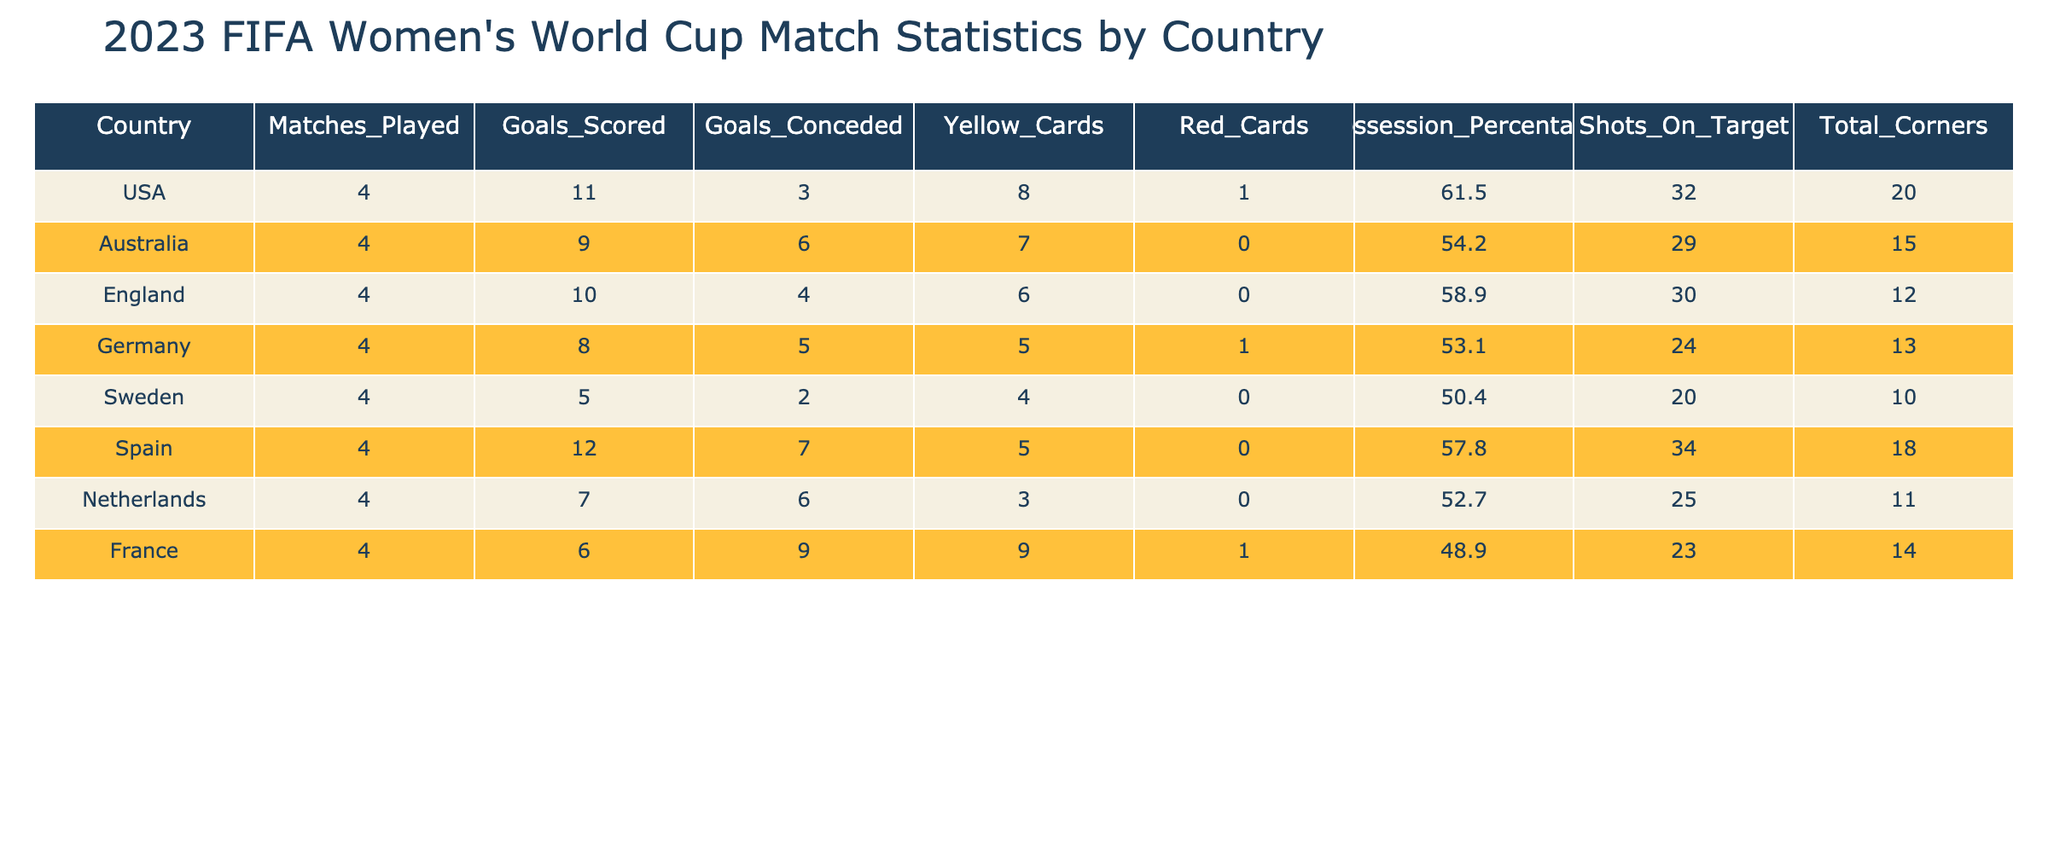What country scored the most goals? The table shows the "Goals_Scored" column for each country. By looking at the figures, Spain scored the most goals with a total of 12.
Answer: Spain Which country had the highest possession percentage? The "Possession_Percentage" column indicates how much time each country possessed the ball. The USA had the highest possession percentage at 61.5.
Answer: USA Did any country receive more than 9 yellow cards? By examining the "Yellow_Cards" column, the highest number listed is 9, which was received by France. Since no country has more than 9 yellow cards, the answer is no.
Answer: No What is the total number of goals scored by all the countries? To find the total goals scored, we sum the "Goals_Scored" column: 11 + 9 + 10 + 8 + 5 + 12 + 7 + 6 = 68.
Answer: 68 Which country had the lowest number of shots on target? In the "Shots_On_Target" column, Sweden has the lowest figure at 20 shots on target.
Answer: Sweden What is the difference in goals scored between the USA and Germany? Looking at the "Goals_Scored" column, the USA scored 11 goals and Germany scored 8 goals. The difference is 11 - 8 = 3.
Answer: 3 Which country had the lowest goals conceded? A quick scan of the "Goals_Conceded" column shows that Sweden conceded the least number of goals, with only 2.
Answer: Sweden What is the average number of yellow cards given across all countries? To calculate the average yellow cards, we sum the values in the "Yellow_Cards" column (8 + 7 + 6 + 5 + 4 + 5 + 3 + 9 = 47) and divide by the number of countries (8): 47 / 8 = 5.875, rounded to 5.88.
Answer: 5.88 Did England have a better goal difference than France? To find the goal difference, subtract "Goals_Conceded" from "Goals_Scored." England's goal difference is 10 - 4 = 6, while France's is 6 - 9 = -3. Since 6 is greater than -3, England does have a better goal difference than France.
Answer: Yes 